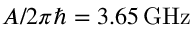Convert formula to latex. <formula><loc_0><loc_0><loc_500><loc_500>A / 2 \pi \hbar { = } 3 . 6 5 \, G H z</formula> 